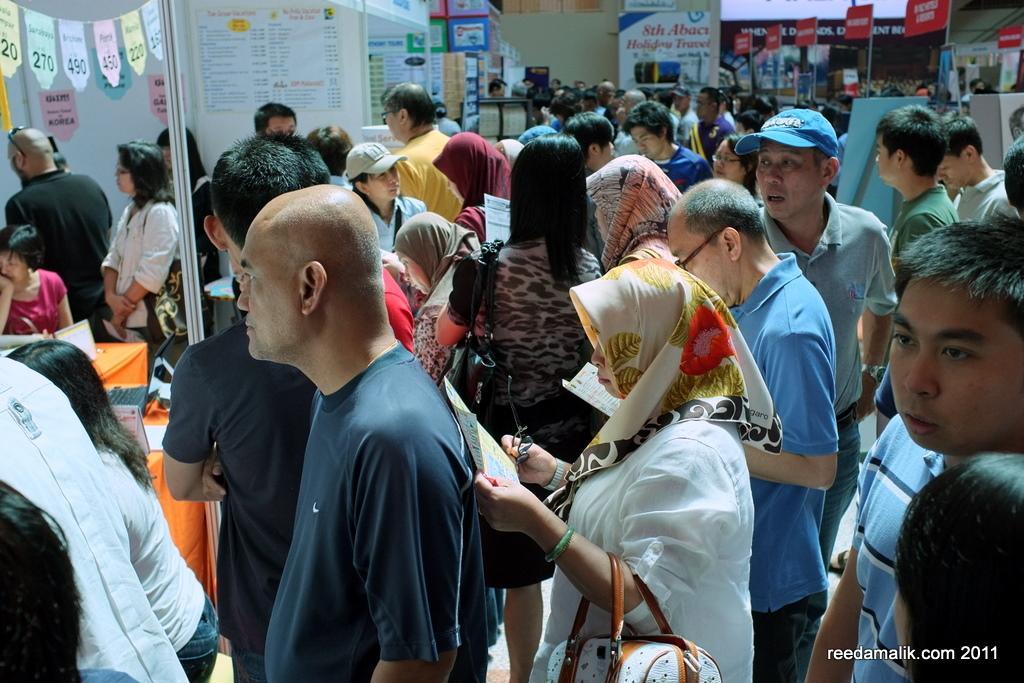How would you summarize this image in a sentence or two? In this picture there are people and we can see stalls, boards, pole, hoardings, posters and objects. 